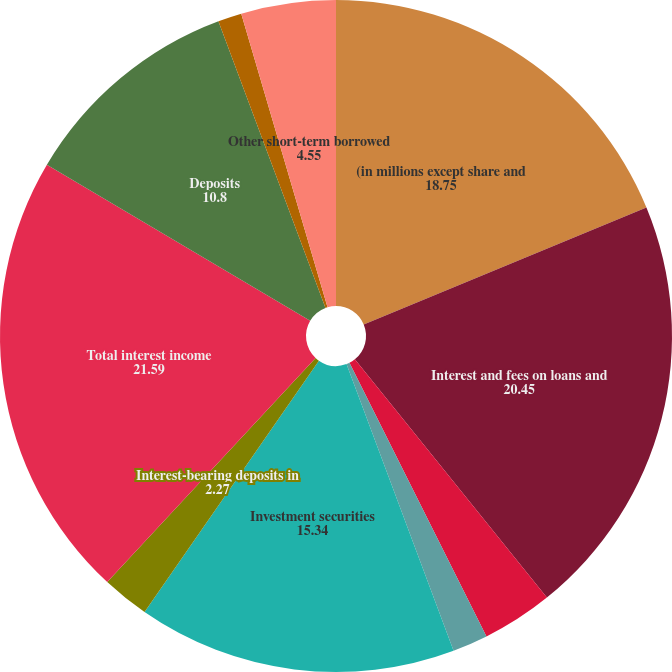Convert chart. <chart><loc_0><loc_0><loc_500><loc_500><pie_chart><fcel>(in millions except share and<fcel>Interest and fees on loans and<fcel>Interest and fees on loans<fcel>Interest and fees on other<fcel>Investment securities<fcel>Interest-bearing deposits in<fcel>Total interest income<fcel>Deposits<fcel>Federal funds purchased and<fcel>Other short-term borrowed<nl><fcel>18.75%<fcel>20.45%<fcel>3.41%<fcel>1.7%<fcel>15.34%<fcel>2.27%<fcel>21.59%<fcel>10.8%<fcel>1.14%<fcel>4.55%<nl></chart> 